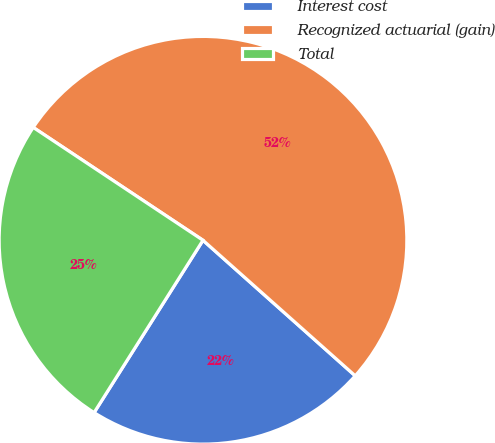<chart> <loc_0><loc_0><loc_500><loc_500><pie_chart><fcel>Interest cost<fcel>Recognized actuarial (gain)<fcel>Total<nl><fcel>22.39%<fcel>52.24%<fcel>25.37%<nl></chart> 